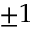Convert formula to latex. <formula><loc_0><loc_0><loc_500><loc_500>\pm 1</formula> 